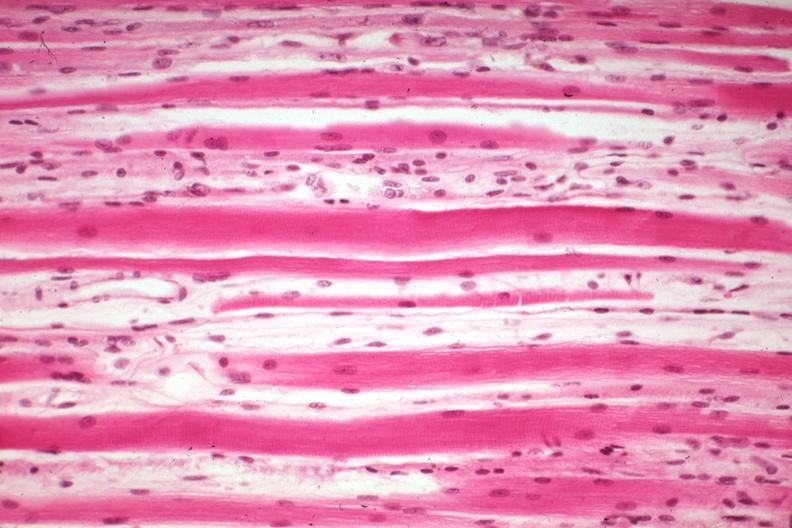what is present?
Answer the question using a single word or phrase. Muscle 